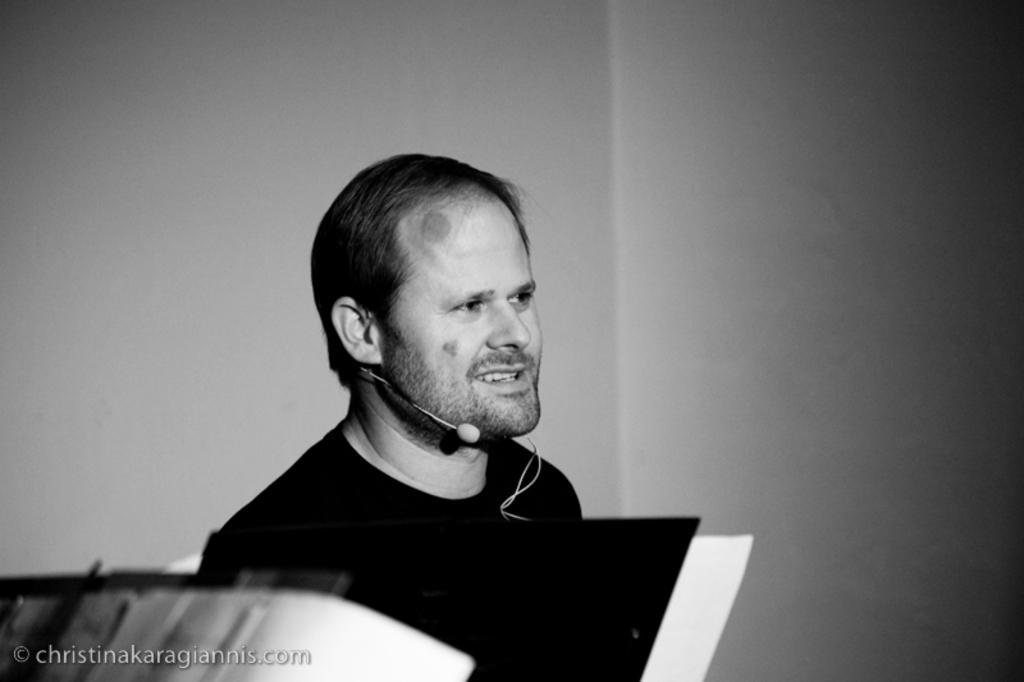In one or two sentences, can you explain what this image depicts? In this image, we can see a person is smiling and looking at the right side. At the bottom, we can see the papers. Here there is a watermark in the image. Background there is a wall. 